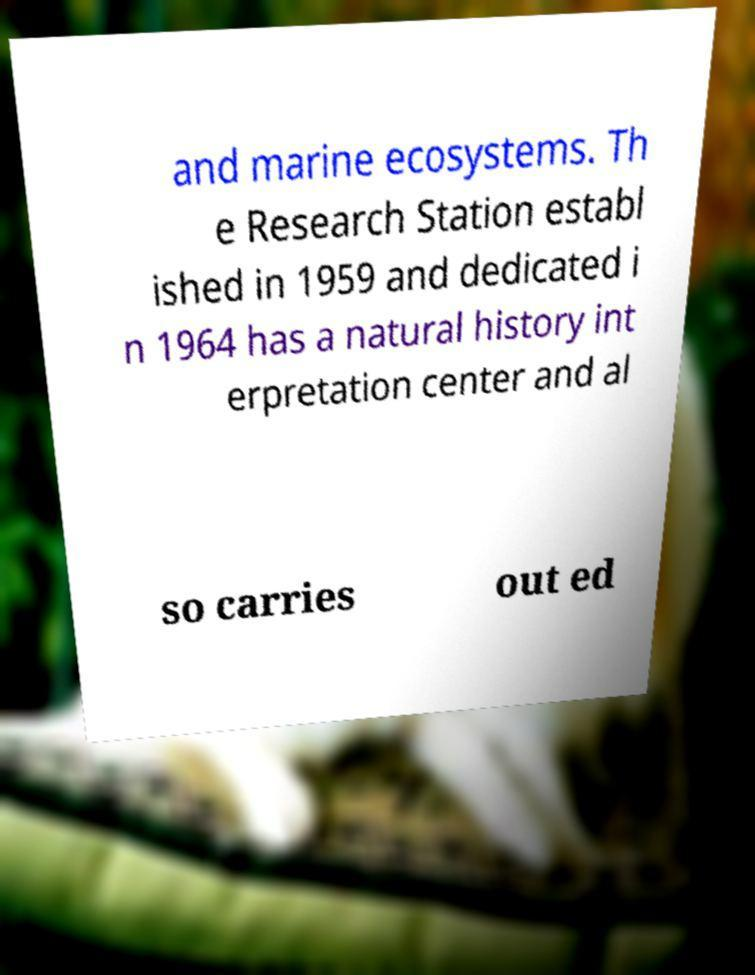Can you read and provide the text displayed in the image?This photo seems to have some interesting text. Can you extract and type it out for me? and marine ecosystems. Th e Research Station establ ished in 1959 and dedicated i n 1964 has a natural history int erpretation center and al so carries out ed 